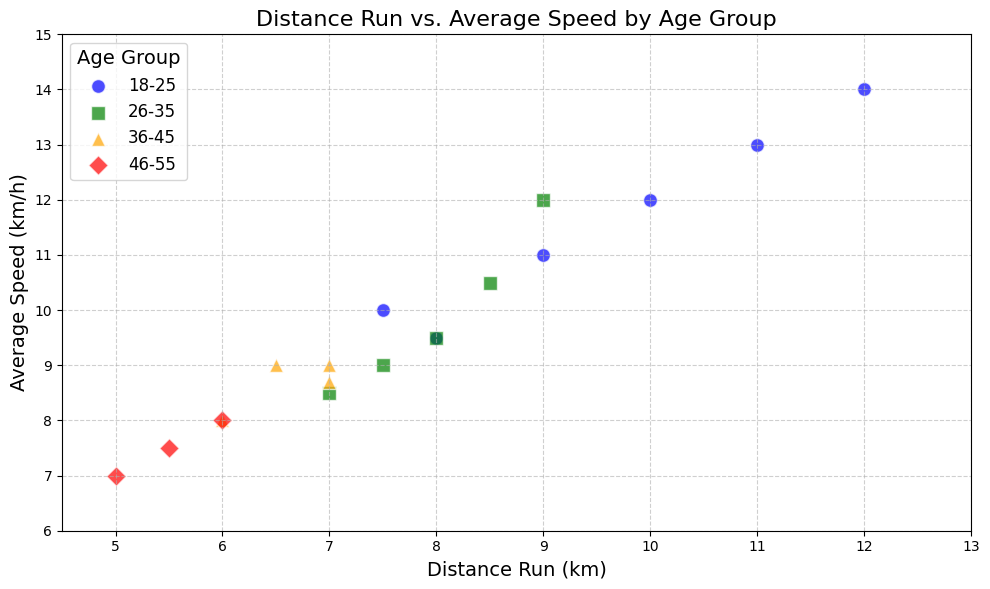What's the relationship between average speed and distance run for the 18-25 age group? To determine the relationship, observe the positions of the blue circles representing the 18-25 age group. They generally trend upwards from left to right, suggesting that within the age group, higher distances correlate with higher speeds.
Answer: Positive correlation Which age group has the highest average speed for a given distance? In the figure, compare the heights of the markers (which represent average speed) across different age groups for similar distances. The blue circles (18-25 age group) are consistently higher than the other age groups, indicating they have the highest average speed for a given distance.
Answer: 18-25 What is the average speed for the 46-55 age group when they run 6 km? Locate the red diamonds (representing the 46-55 age group) along the 6 km distance mark on the x-axis. There is only one red diamond at 6 km, which has an average speed of 8 km/h.
Answer: 8 km/h Which age group covers the greatest distance? Examine the colors and symbols representing each age group along the x-axis. The highest point on the x-axis is a blue circle (18-25 age group) at 12 km.
Answer: 18-25 For which age group does average speed seem least affected by an increase in distance run? Observe the variation in speed markers (height on the y-axis) within each age group as distance increases. The red diamonds (46-55 age group) show relatively little change in height, indicating their speed is least affected by distance.
Answer: 46-55 Among the data points for the 36-45 age group, what is the shortest distance run? Look for the orange triangles representing the 36-45 age group. The smallest x-axis value for the orange triangles is 6 km.
Answer: 6 km Compare the average speed for the age groups 26-35 and 36-45 at around 7 km of distance run. Which one runs faster? Find the markers for both the green squares (26-35) and orange triangles (36-45) at approximately the 7 km mark. The green square sits higher on the y-axis than the orange triangle, indicating the 26-35 age group runs faster.
Answer: 26-35 How does the distance run by the 46-55 age group compare to the distance run by the 18-25 age group? Observe the red diamonds (46-55) and blue circles (18-25) on the x-axis. The red diamonds are more towards the left, and the blue circles towards the right. This suggests that the 18-25 age group generally runs longer distances than the 46-55 age group.
Answer: 18-25 runs longer distances What is the trend of average speed for the 26-35 age group as the distance run increases? Look at the green squares representing the 26-35 age group. There is a general upward trend in the position of the markers from left to right, indicating that as the distance run increases, average speed also increases for this age group.
Answer: Increases For the 18-25 age group, what is the difference in average speed between the highest and lowest distances run? Identify the highest and lowest blue circles on the x-axis and compare their y-axis values. The highest distance (12 km) has an average speed of 14 km/h, and the lowest (7.5 km) has an average speed of 10 km/h. The difference is 14 - 10 = 4 km/h.
Answer: 4 km/h 